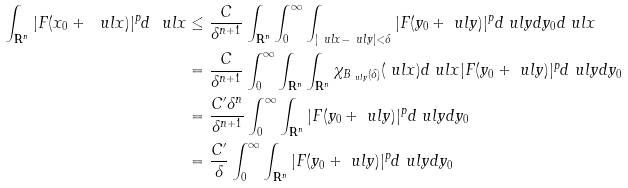<formula> <loc_0><loc_0><loc_500><loc_500>\int _ { \mathbf R ^ { n } } | F ( x _ { 0 } + \ u l x ) | ^ { p } d \ u l x & \leq \frac { C } { \delta ^ { n + 1 } } \int _ { \mathbf R ^ { n } } \int _ { 0 } ^ { \infty } \int _ { | \ u l x - \ u l y | < \delta } | F ( y _ { 0 } + \ u l y ) | ^ { p } d \ u l y d y _ { 0 } d \ u l x \\ & = \frac { C } { \delta ^ { n + 1 } } \int _ { 0 } ^ { \infty } \int _ { \mathbf R ^ { n } } \int _ { \mathbf R ^ { n } } \chi _ { B _ { \ u l y } ( \delta ) } ( \ u l x ) d \ u l x | F ( y _ { 0 } + \ u l y ) | ^ { p } d \ u l y d y _ { 0 } \\ & = \frac { C ^ { \prime } \delta ^ { n } } { \delta ^ { n + 1 } } \int _ { 0 } ^ { \infty } \int _ { \mathbf R ^ { n } } | F ( y _ { 0 } + \ u l y ) | ^ { p } d \ u l y d y _ { 0 } \\ & = \frac { C ^ { \prime } } { \delta } \int _ { 0 } ^ { \infty } \int _ { \mathbf R ^ { n } } | F ( y _ { 0 } + \ u l y ) | ^ { p } d \ u l y d y _ { 0 }</formula> 